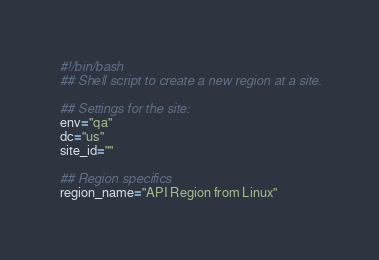<code> <loc_0><loc_0><loc_500><loc_500><_Bash_>#!/bin/bash
## Shell script to create a new region at a site.

## Settings for the site:
env="qa"
dc="us"
site_id=""

## Region specifics
region_name="API Region from Linux"</code> 